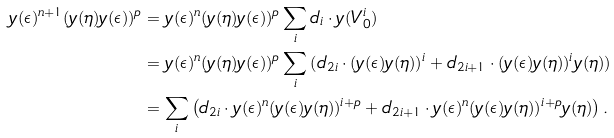Convert formula to latex. <formula><loc_0><loc_0><loc_500><loc_500>y ( \epsilon ) ^ { n + 1 } ( y ( \eta ) y ( \epsilon ) ) ^ { p } & = y ( \epsilon ) ^ { n } ( y ( \eta ) y ( \epsilon ) ) ^ { p } \sum _ { i } d _ { i } \cdot y ( V _ { 0 } ^ { i } ) \\ & = y ( \epsilon ) ^ { n } ( y ( \eta ) y ( \epsilon ) ) ^ { p } \sum _ { i } \left ( d _ { 2 i } \cdot ( y ( \epsilon ) y ( \eta ) ) ^ { i } + d _ { 2 i + 1 } \cdot ( y ( \epsilon ) y ( \eta ) ) ^ { i } y ( \eta ) \right ) \\ & = \sum _ { i } \left ( d _ { 2 i } \cdot y ( \epsilon ) ^ { n } ( y ( \epsilon ) y ( \eta ) ) ^ { i + p } + d _ { 2 i + 1 } \cdot y ( \epsilon ) ^ { n } ( y ( \epsilon ) y ( \eta ) ) ^ { i + p } y ( \eta ) \right ) .</formula> 